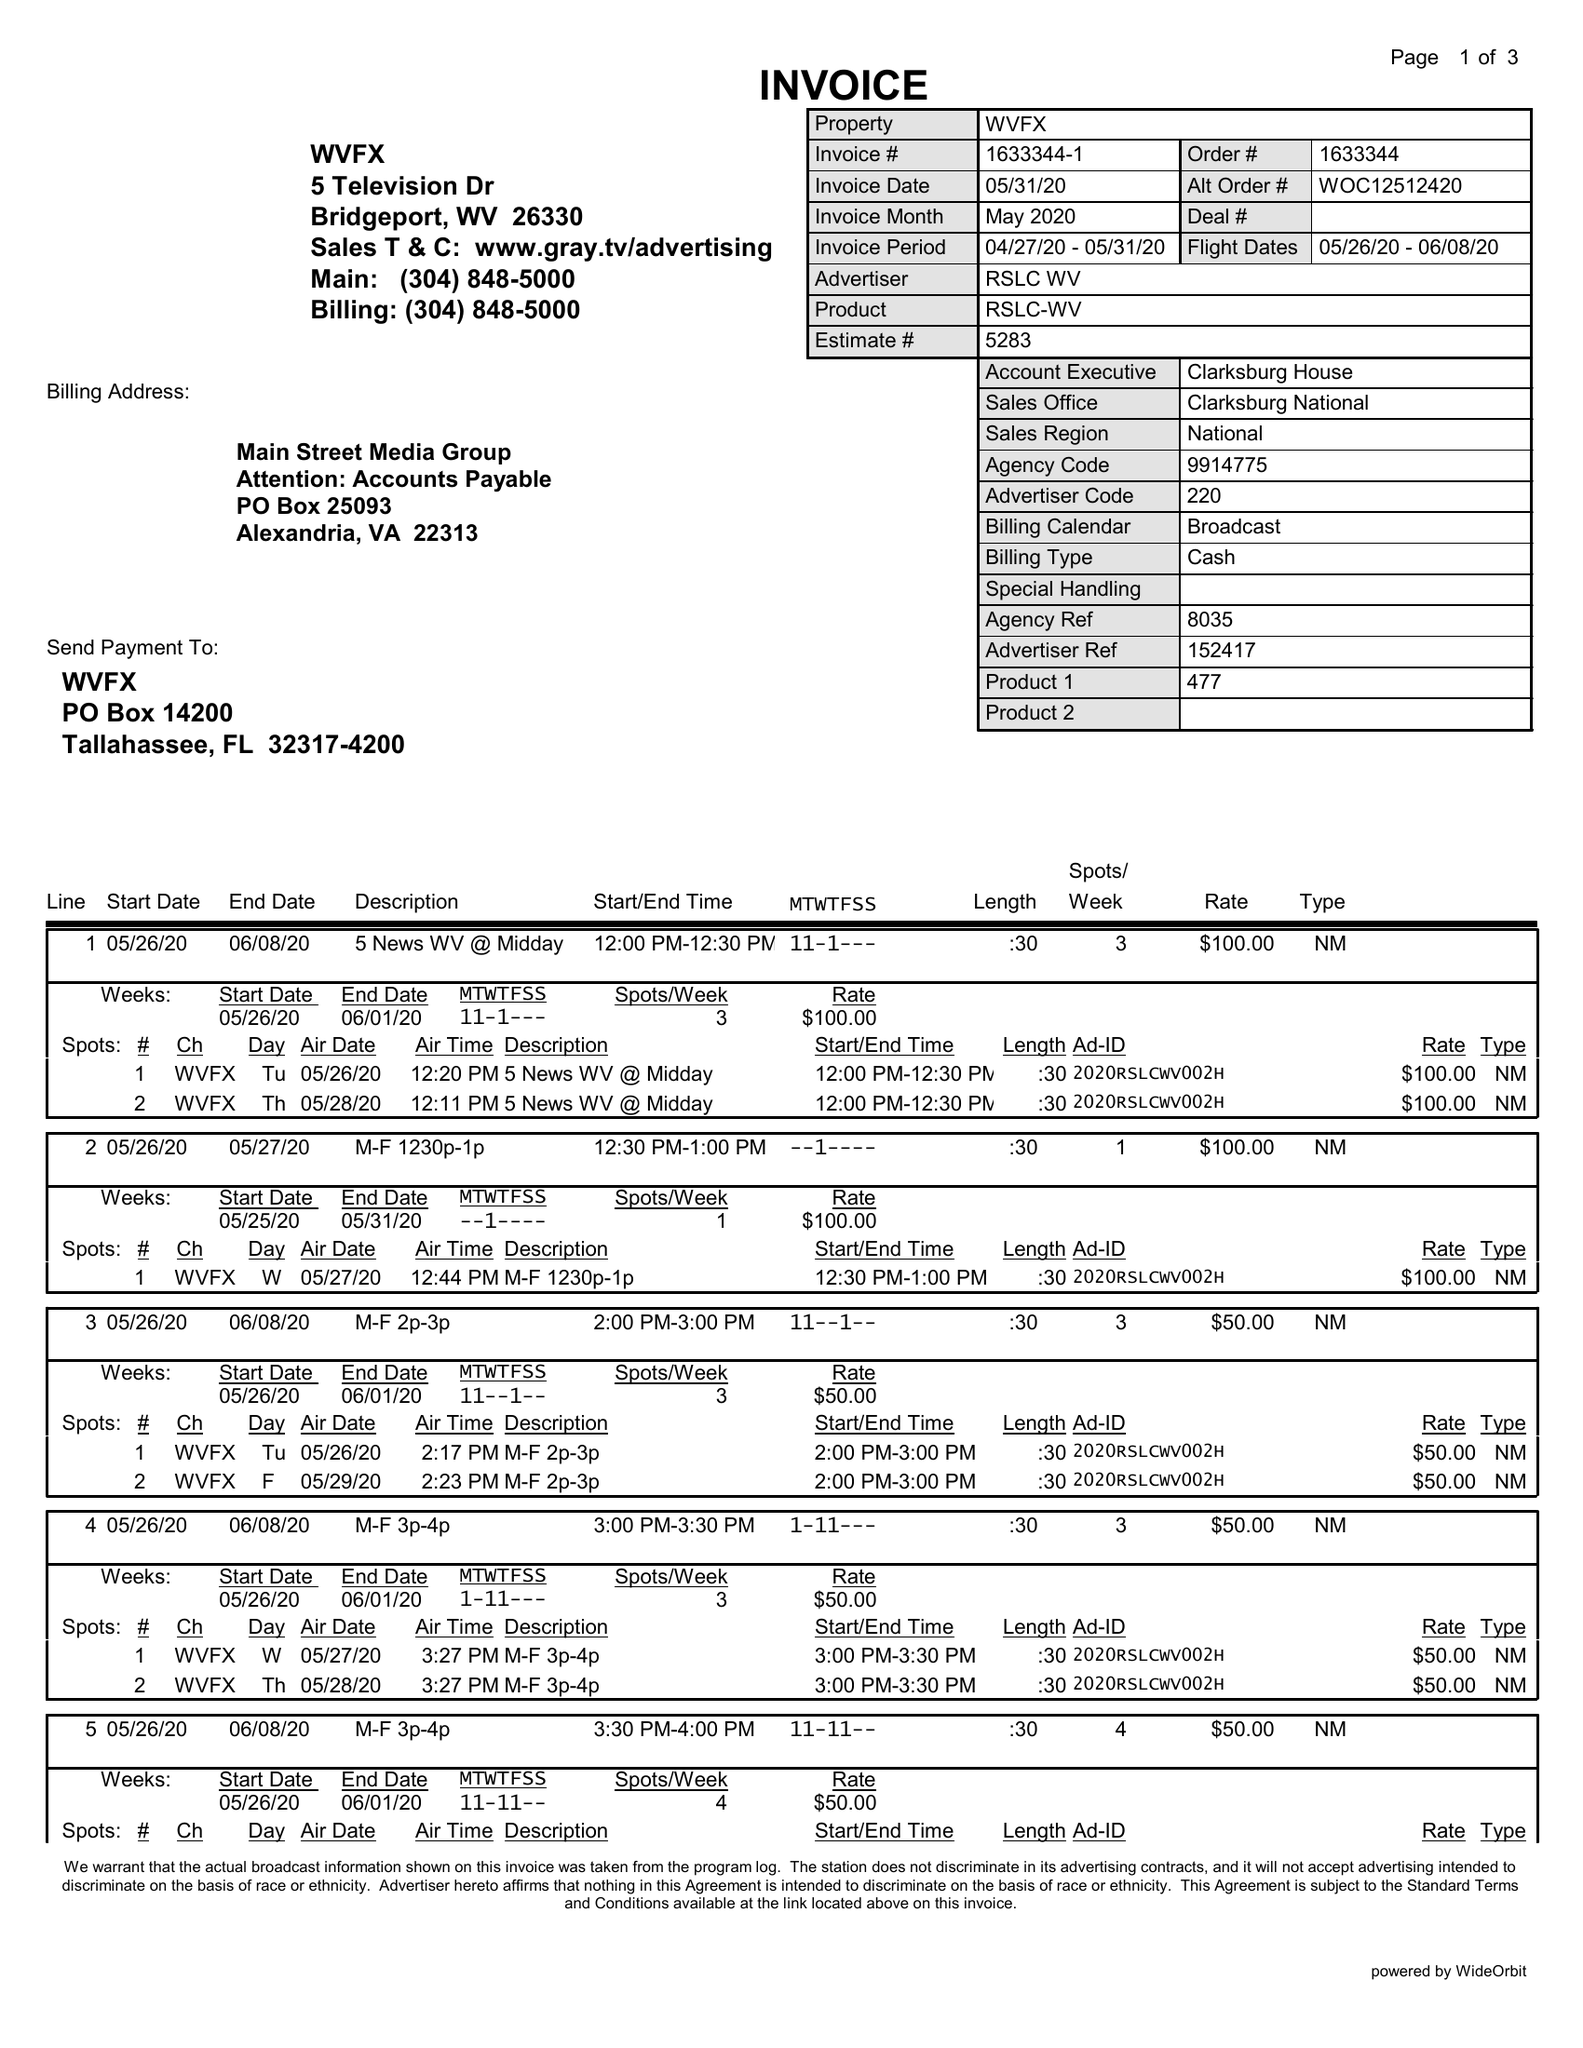What is the value for the contract_num?
Answer the question using a single word or phrase. 1633344 